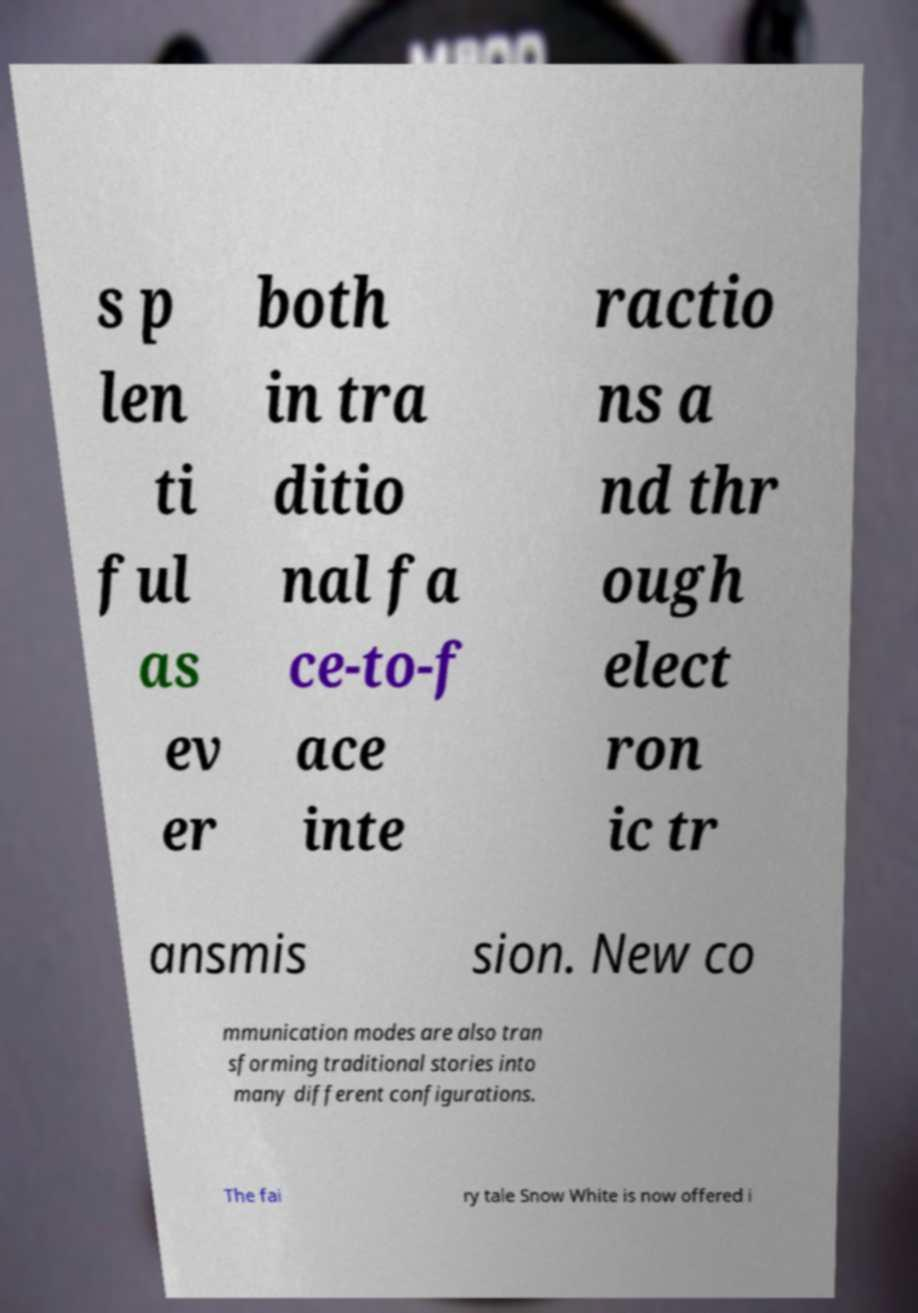For documentation purposes, I need the text within this image transcribed. Could you provide that? s p len ti ful as ev er both in tra ditio nal fa ce-to-f ace inte ractio ns a nd thr ough elect ron ic tr ansmis sion. New co mmunication modes are also tran sforming traditional stories into many different configurations. The fai ry tale Snow White is now offered i 